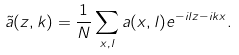<formula> <loc_0><loc_0><loc_500><loc_500>\tilde { a } ( z , k ) = \frac { 1 } { N } \sum _ { x , l } a ( x , l ) e ^ { - i l z - i k x } .</formula> 